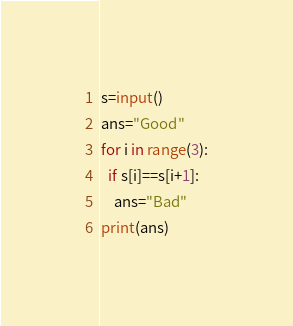<code> <loc_0><loc_0><loc_500><loc_500><_Python_>s=input()
ans="Good"
for i in range(3):
  if s[i]==s[i+1]:
    ans="Bad"
print(ans)</code> 